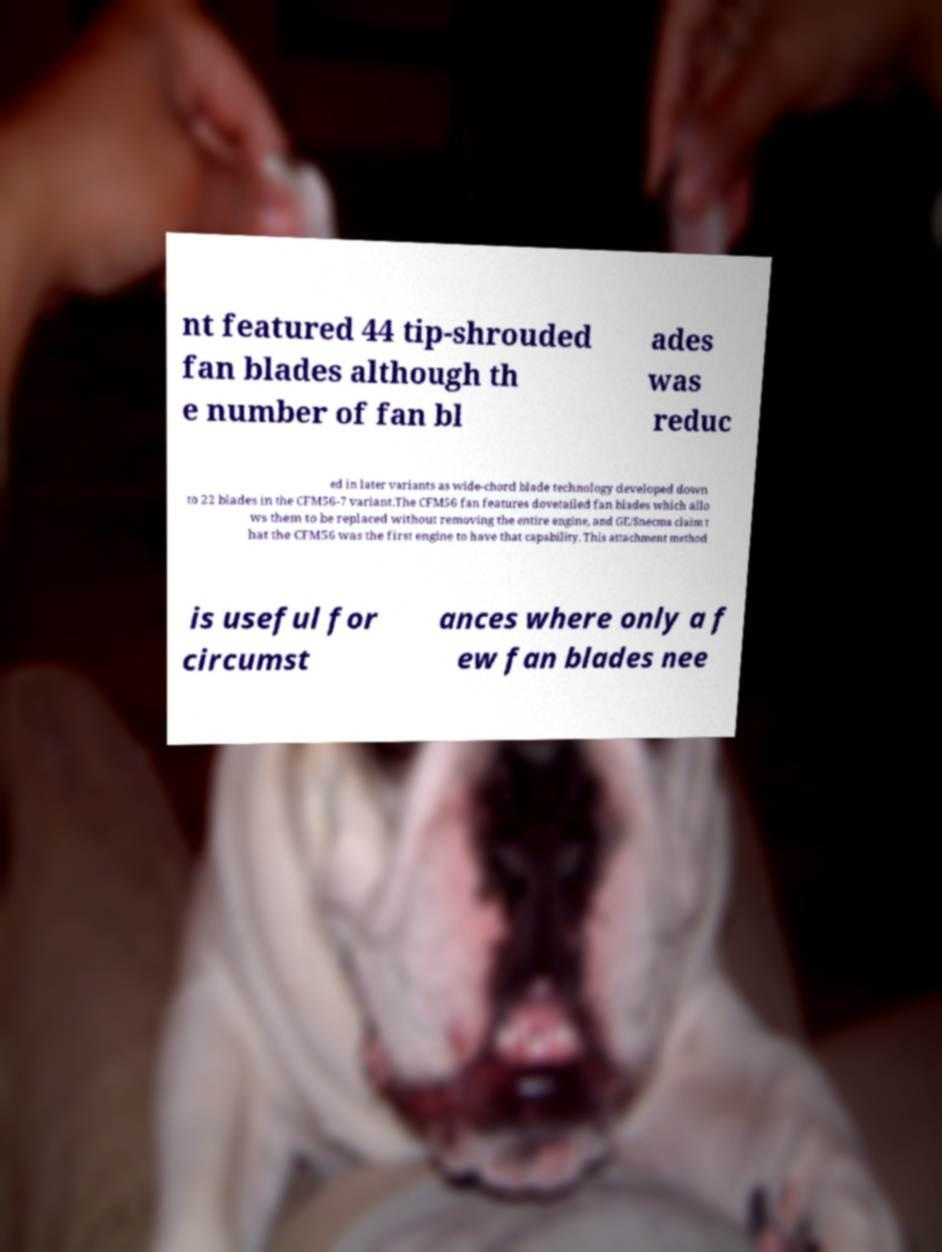Could you extract and type out the text from this image? nt featured 44 tip-shrouded fan blades although th e number of fan bl ades was reduc ed in later variants as wide-chord blade technology developed down to 22 blades in the CFM56-7 variant.The CFM56 fan features dovetailed fan blades which allo ws them to be replaced without removing the entire engine, and GE/Snecma claim t hat the CFM56 was the first engine to have that capability. This attachment method is useful for circumst ances where only a f ew fan blades nee 